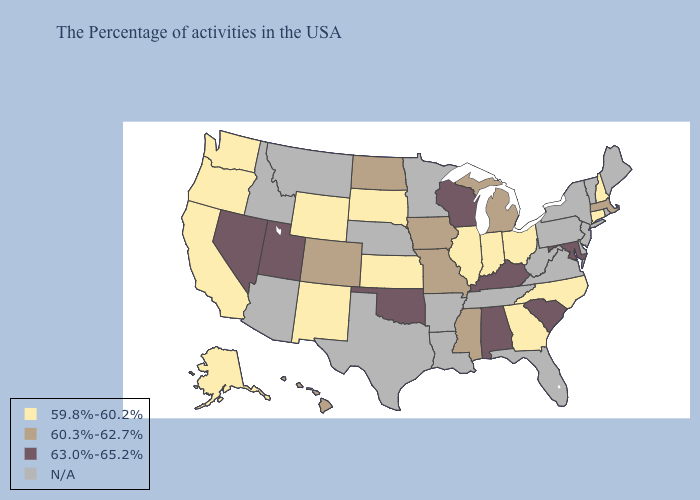Name the states that have a value in the range N/A?
Be succinct. Maine, Rhode Island, Vermont, New York, New Jersey, Delaware, Pennsylvania, Virginia, West Virginia, Florida, Tennessee, Louisiana, Arkansas, Minnesota, Nebraska, Texas, Montana, Arizona, Idaho. What is the value of Texas?
Short answer required. N/A. Does the first symbol in the legend represent the smallest category?
Concise answer only. Yes. Which states have the highest value in the USA?
Answer briefly. Maryland, South Carolina, Kentucky, Alabama, Wisconsin, Oklahoma, Utah, Nevada. Among the states that border Indiana , does Michigan have the lowest value?
Be succinct. No. Which states hav the highest value in the South?
Be succinct. Maryland, South Carolina, Kentucky, Alabama, Oklahoma. Name the states that have a value in the range 60.3%-62.7%?
Write a very short answer. Massachusetts, Michigan, Mississippi, Missouri, Iowa, North Dakota, Colorado, Hawaii. Does the map have missing data?
Keep it brief. Yes. What is the value of Montana?
Write a very short answer. N/A. What is the highest value in states that border Mississippi?
Keep it brief. 63.0%-65.2%. Does Nevada have the highest value in the West?
Answer briefly. Yes. Does Iowa have the lowest value in the MidWest?
Quick response, please. No. Name the states that have a value in the range 63.0%-65.2%?
Concise answer only. Maryland, South Carolina, Kentucky, Alabama, Wisconsin, Oklahoma, Utah, Nevada. Does Mississippi have the lowest value in the USA?
Answer briefly. No. What is the highest value in the South ?
Answer briefly. 63.0%-65.2%. 